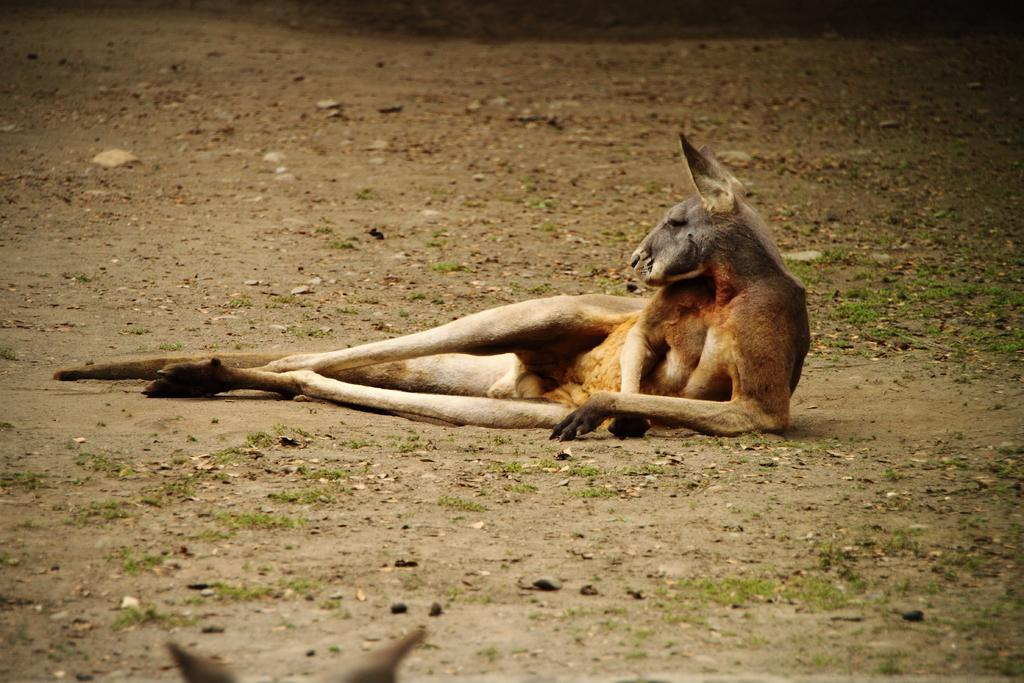What type of creature is present in the image? There is an animal in the image. Can you describe the position of the animal in the image? The animal is on the ground. What type of cherries can be seen growing on the animal in the image? There are no cherries present in the image, nor are they growing on the animal. 